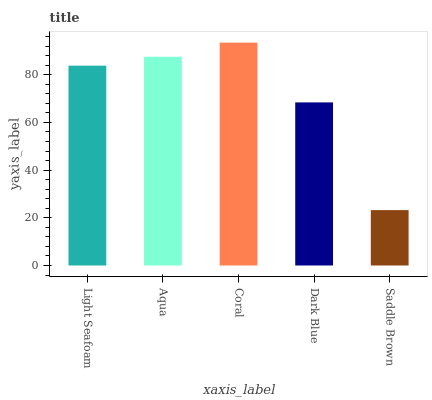Is Saddle Brown the minimum?
Answer yes or no. Yes. Is Coral the maximum?
Answer yes or no. Yes. Is Aqua the minimum?
Answer yes or no. No. Is Aqua the maximum?
Answer yes or no. No. Is Aqua greater than Light Seafoam?
Answer yes or no. Yes. Is Light Seafoam less than Aqua?
Answer yes or no. Yes. Is Light Seafoam greater than Aqua?
Answer yes or no. No. Is Aqua less than Light Seafoam?
Answer yes or no. No. Is Light Seafoam the high median?
Answer yes or no. Yes. Is Light Seafoam the low median?
Answer yes or no. Yes. Is Saddle Brown the high median?
Answer yes or no. No. Is Dark Blue the low median?
Answer yes or no. No. 